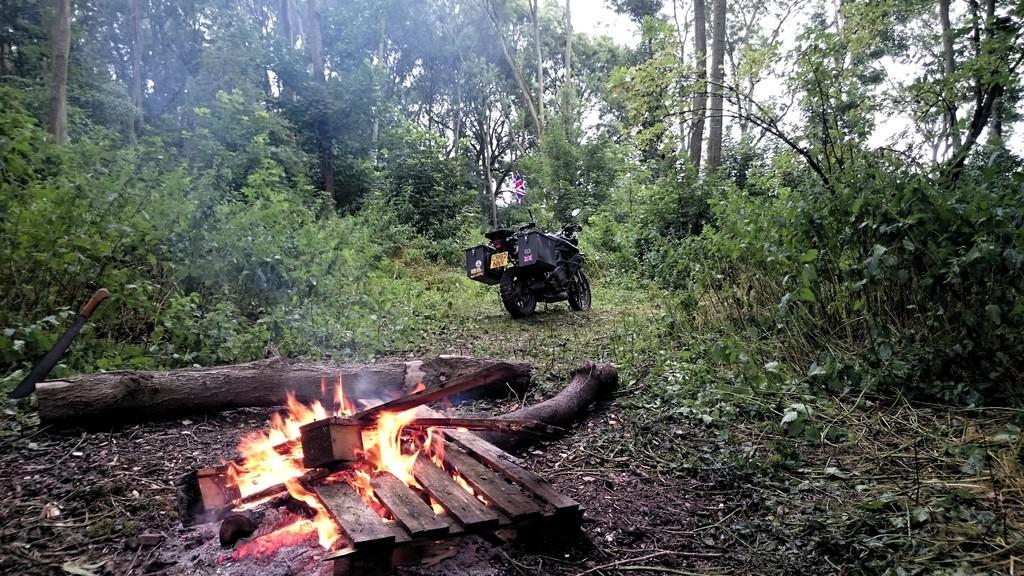What can be seen on the land in the image? There is burnt wood on the land in the image. What is present near the burnt wood? There are plants and trees around the burnt wood. Can you describe the vehicle in the image? There is a vehicle parked among the plants in the image. What type of lipstick is the image? There is no lipstick or any reference to lips in the image; it features burnt wood, plants, trees, and a parked vehicle. 